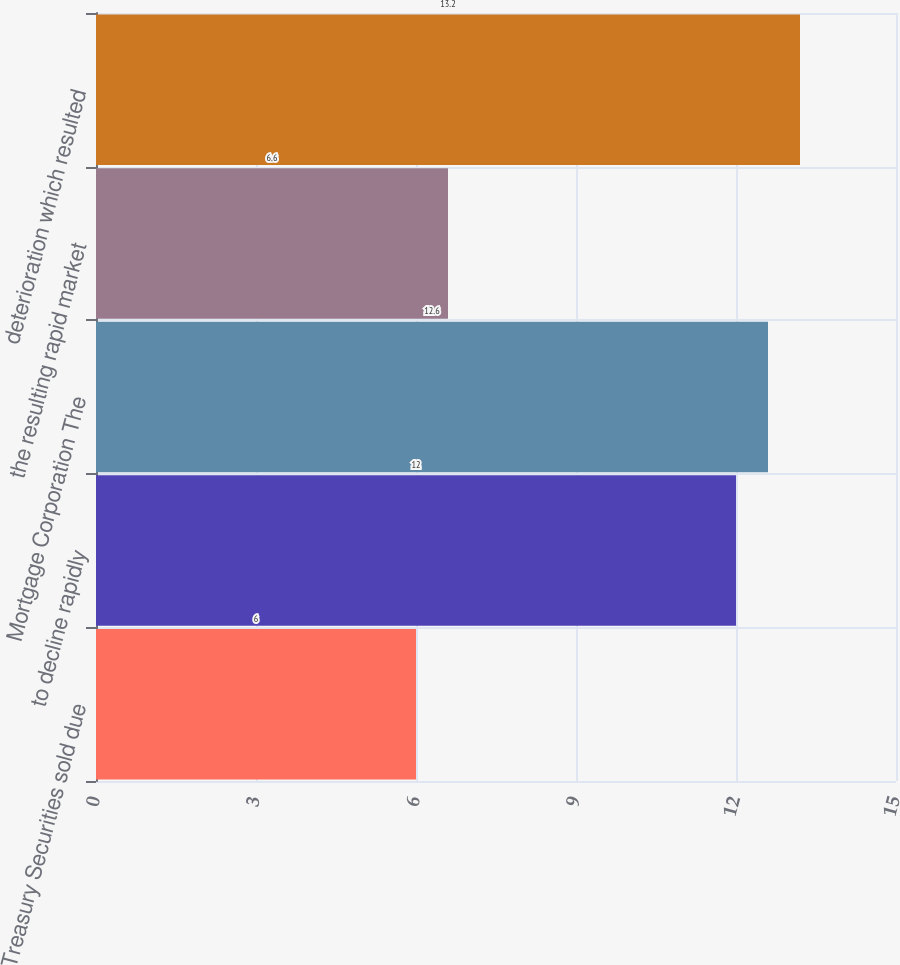Convert chart. <chart><loc_0><loc_0><loc_500><loc_500><bar_chart><fcel>Treasury Securities sold due<fcel>to decline rapidly<fcel>Mortgage Corporation The<fcel>the resulting rapid market<fcel>deterioration which resulted<nl><fcel>6<fcel>12<fcel>12.6<fcel>6.6<fcel>13.2<nl></chart> 